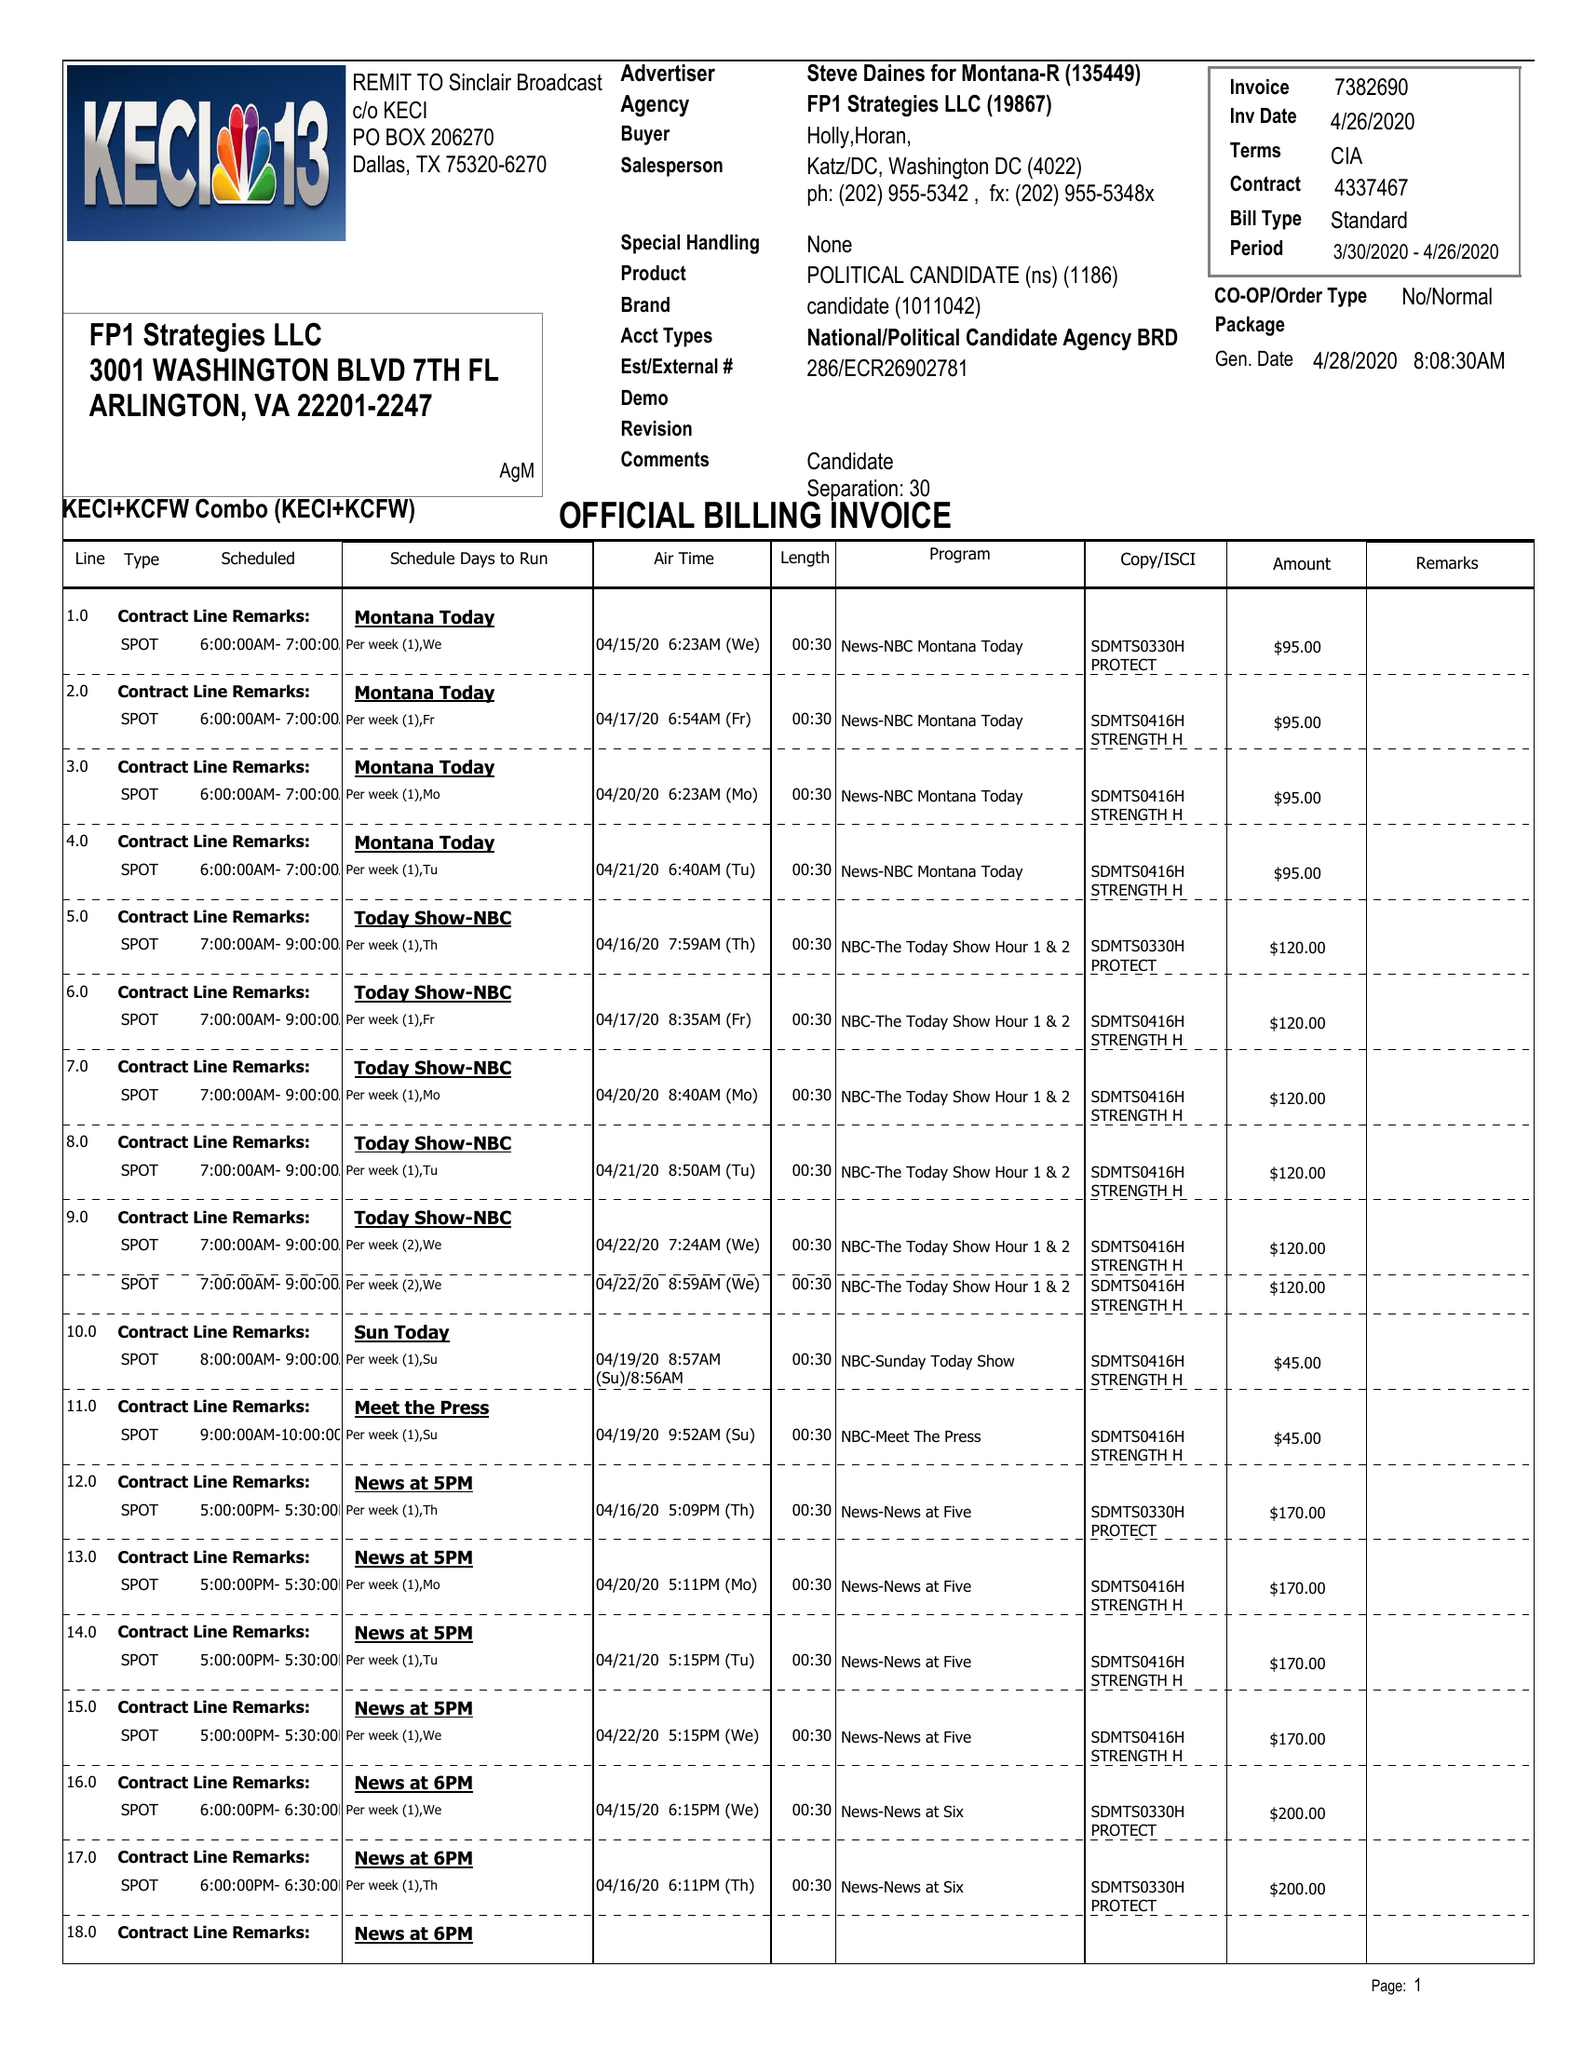What is the value for the flight_from?
Answer the question using a single word or phrase. 03/30/20 